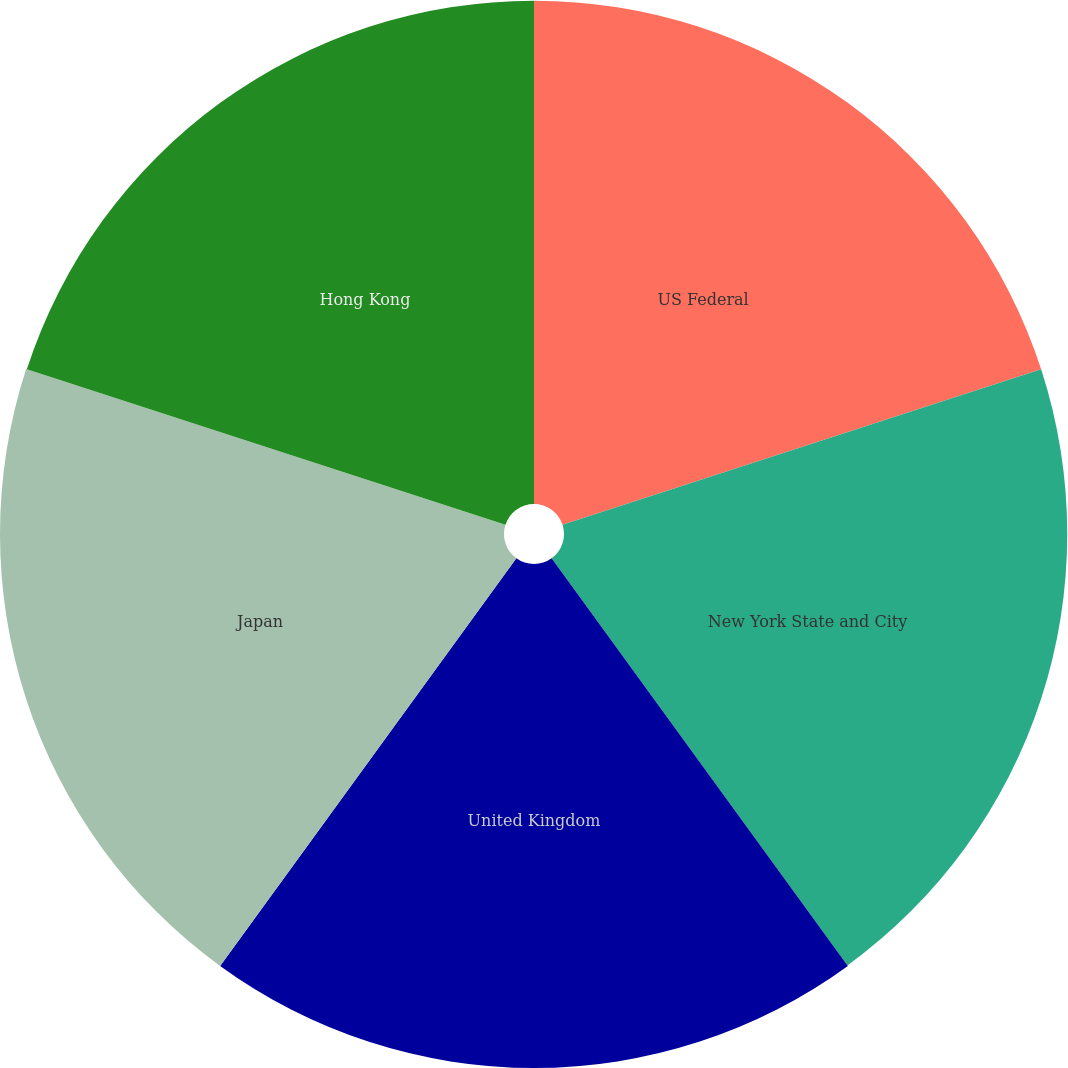Convert chart to OTSL. <chart><loc_0><loc_0><loc_500><loc_500><pie_chart><fcel>US Federal<fcel>New York State and City<fcel>United Kingdom<fcel>Japan<fcel>Hong Kong<nl><fcel>19.99%<fcel>19.99%<fcel>20.02%<fcel>20.02%<fcel>19.99%<nl></chart> 